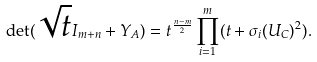Convert formula to latex. <formula><loc_0><loc_0><loc_500><loc_500>\det ( \sqrt { t } I _ { m + n } + Y _ { A } ) = t ^ { \frac { n - m } { 2 } } \prod _ { i = 1 } ^ { m } ( t + \sigma _ { i } ( U _ { C } ) ^ { 2 } ) .</formula> 